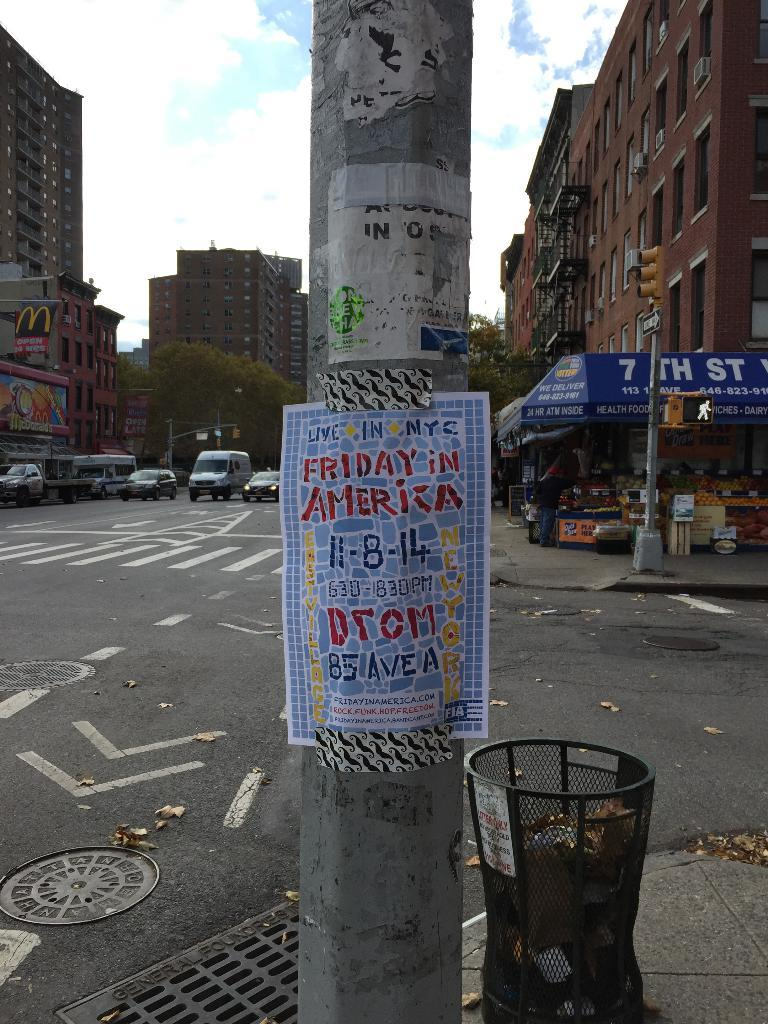<image>
Offer a succinct explanation of the picture presented. a lamp post in an urban street with a poster for Live in NYC 